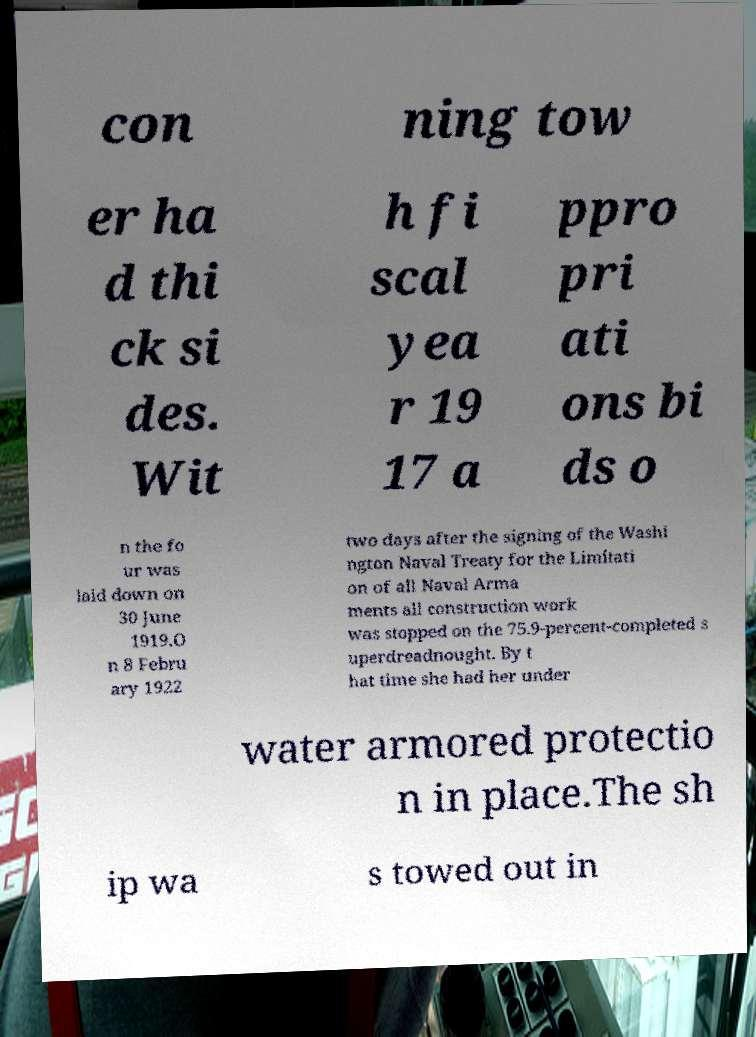What messages or text are displayed in this image? I need them in a readable, typed format. con ning tow er ha d thi ck si des. Wit h fi scal yea r 19 17 a ppro pri ati ons bi ds o n the fo ur was laid down on 30 June 1919.O n 8 Febru ary 1922 two days after the signing of the Washi ngton Naval Treaty for the Limitati on of all Naval Arma ments all construction work was stopped on the 75.9-percent-completed s uperdreadnought. By t hat time she had her under water armored protectio n in place.The sh ip wa s towed out in 